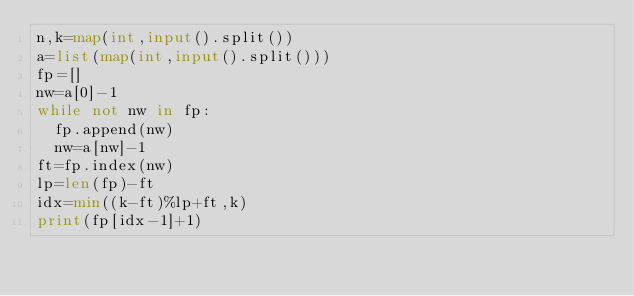<code> <loc_0><loc_0><loc_500><loc_500><_Python_>n,k=map(int,input().split())
a=list(map(int,input().split()))
fp=[]
nw=a[0]-1
while not nw in fp:
  fp.append(nw)
  nw=a[nw]-1
ft=fp.index(nw)
lp=len(fp)-ft
idx=min((k-ft)%lp+ft,k)
print(fp[idx-1]+1)</code> 